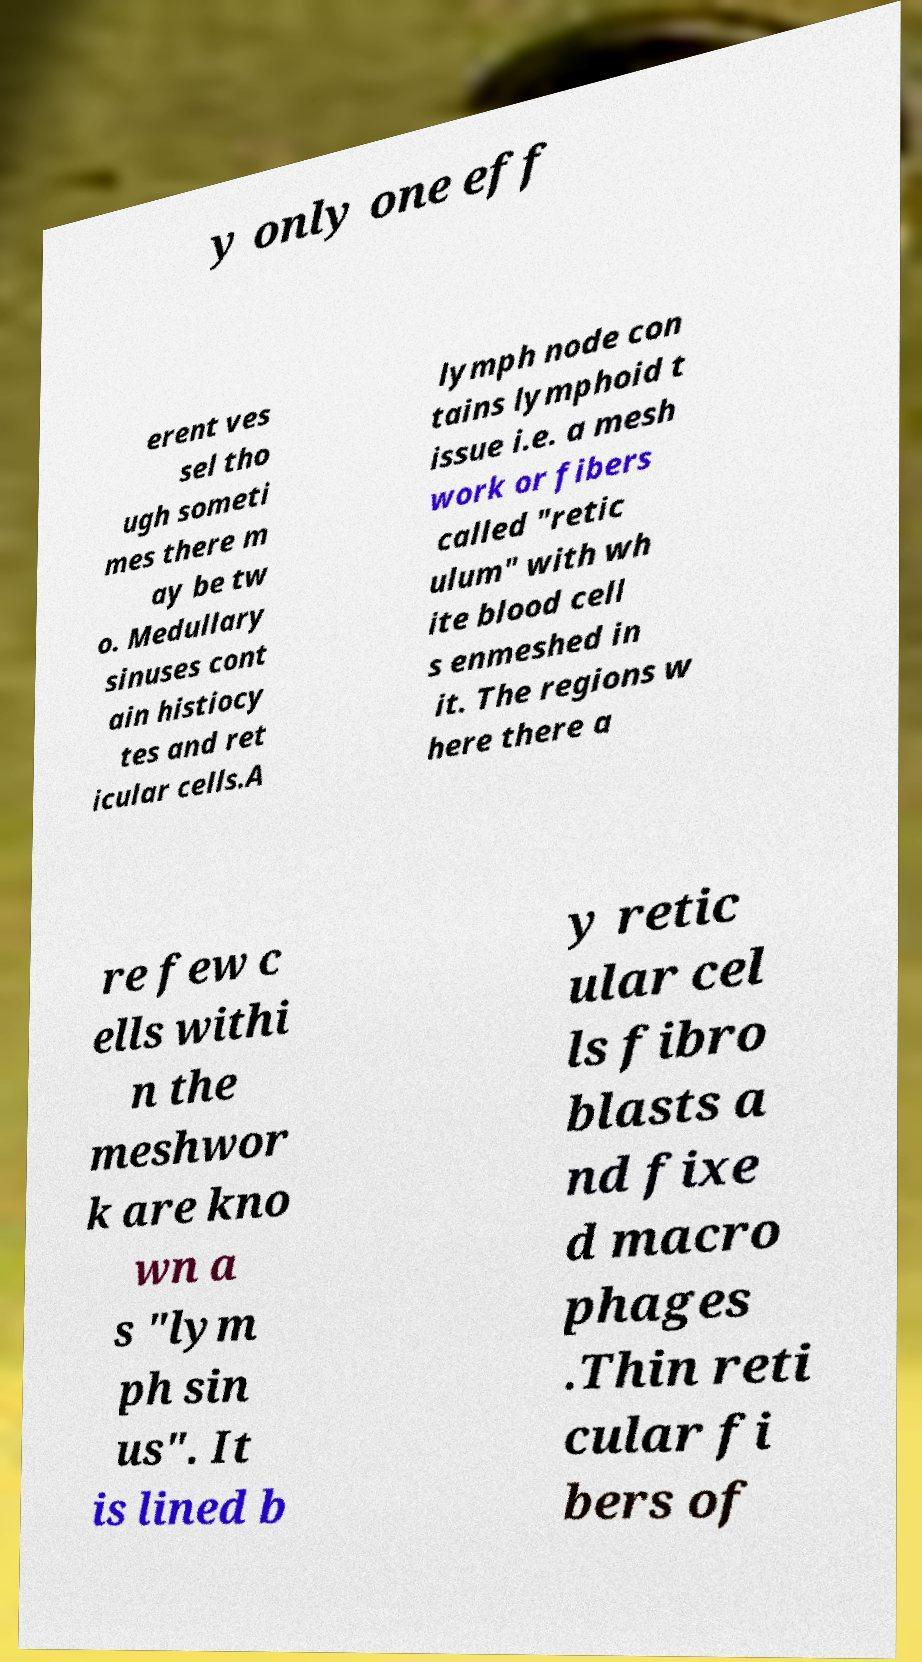What messages or text are displayed in this image? I need them in a readable, typed format. y only one eff erent ves sel tho ugh someti mes there m ay be tw o. Medullary sinuses cont ain histiocy tes and ret icular cells.A lymph node con tains lymphoid t issue i.e. a mesh work or fibers called "retic ulum" with wh ite blood cell s enmeshed in it. The regions w here there a re few c ells withi n the meshwor k are kno wn a s "lym ph sin us". It is lined b y retic ular cel ls fibro blasts a nd fixe d macro phages .Thin reti cular fi bers of 